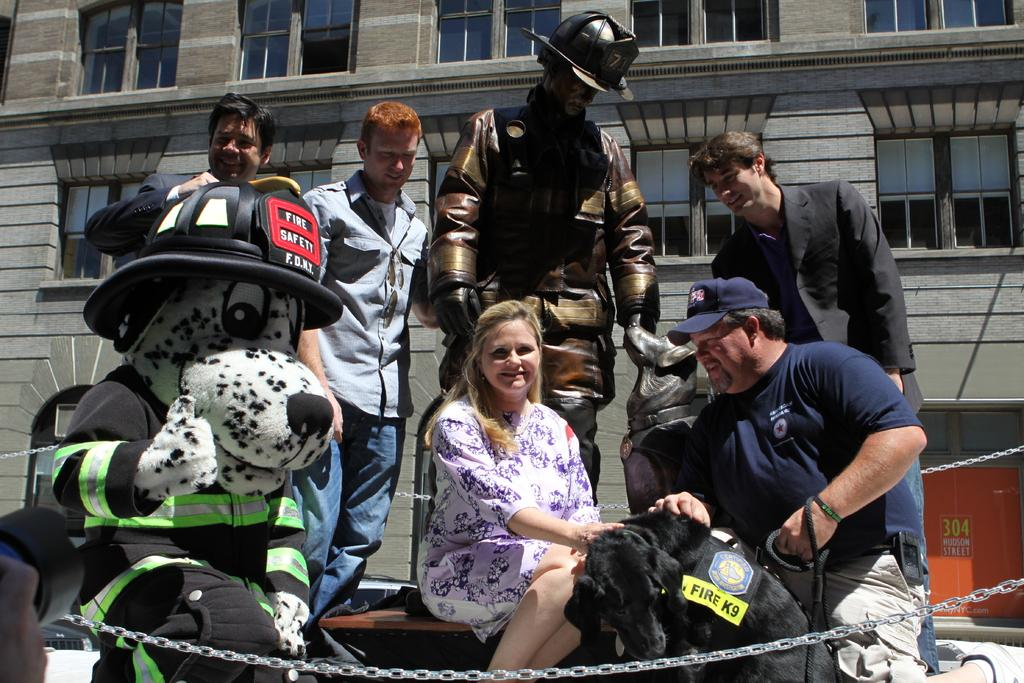How many people are in the group visible in the image? There is a group of people in the image, but the exact number cannot be determined from the provided facts. What is the statue in the image depicting? The provided facts do not specify what the statue is depicting. What is the cap used for in the image? The provided facts do not specify the purpose of the cap in the image. What are the chains connected to in the image? The provided facts do not specify what the chains are connected to in the image. What is the dog doing in the image? The provided facts do not specify the dog's actions or behavior in the image. What type of objects can be seen in the image? A: The provided facts do not specify the type of objects present in the image. What can be seen in the background of the image? There is a building with windows in the background of the image. What type of jam is being spread on the statue in the image? There is no jam present in the image, and the statue is not being interacted with in any way. What type of structure is the dog using to climb up to the cap in the image? There is no structure present in the image, and the dog is not interacting with the cap. 